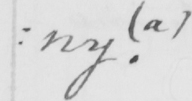Please provide the text content of this handwritten line. : ny .   ( a ) 